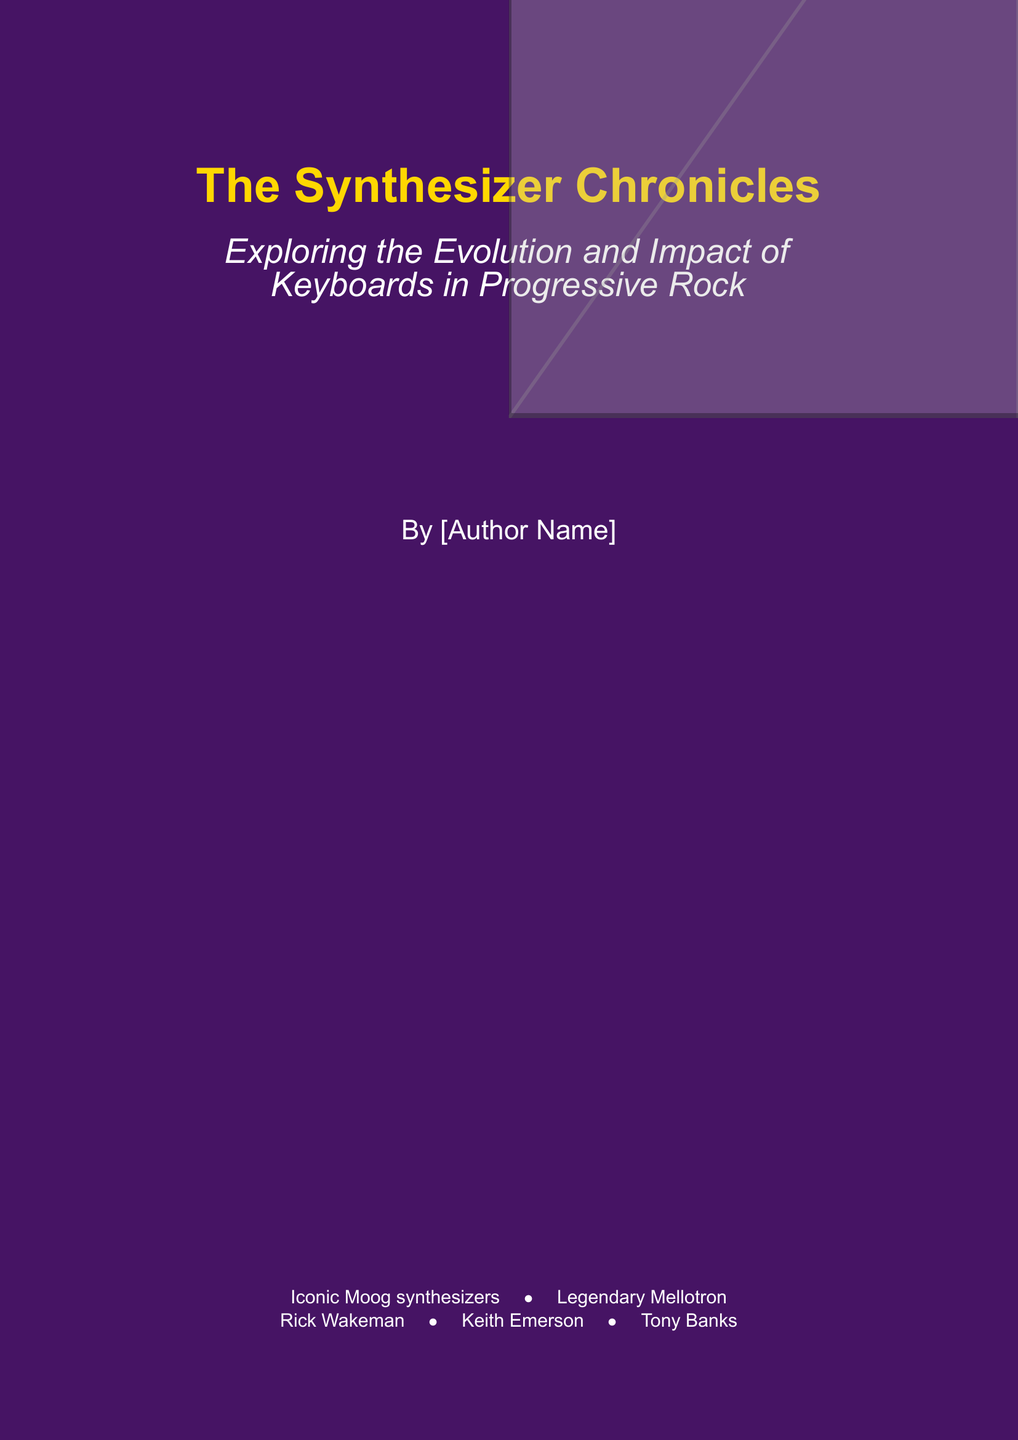What is the title of the book? The title of the book is prominently displayed on the cover in large font.
Answer: The Synthesizer Chronicles Who is the author? The author's name is included near the bottom of the cover.
Answer: [Author Name] What is the subtitle of the book? The subtitle is written in italicized text just below the title.
Answer: Exploring the Evolution and Impact of Keyboards in Progressive Rock Which iconic synthesizers are mentioned? The cover lists some famous synthesizers in a bulleted format.
Answer: Moog synthesizers, Mellotron Which keyboardists are featured? The cover points out legendary keyboardists associated with the genre.
Answer: Rick Wakeman, Keith Emerson, Tony Banks What color is the background of the book cover? The background color is specified in the document.
Answer: Cosmic lavender 